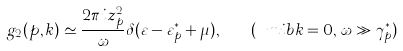<formula> <loc_0><loc_0><loc_500><loc_500>g _ { 2 } ( p , k ) \simeq \frac { 2 \pi i z _ { p } ^ { 2 } } { \omega } \delta ( \varepsilon - \varepsilon ^ { * } _ { p } + \mu ) , \quad ( \ m i b { k } = 0 , \, \omega \gg \gamma _ { p } ^ { * } )</formula> 